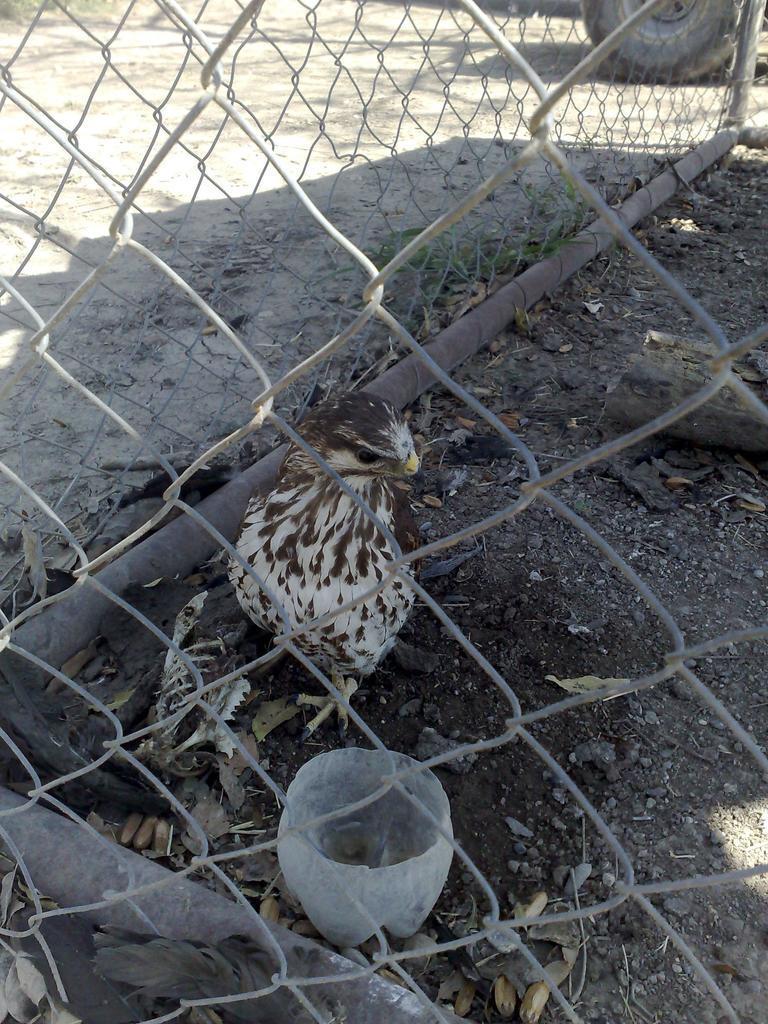Please provide a concise description of this image. In this picture I can see a bird and I can see few leaves and a tree bark on the ground and I can see metal fence and looks like a vehicle wheel on the top right corner of the picture. 